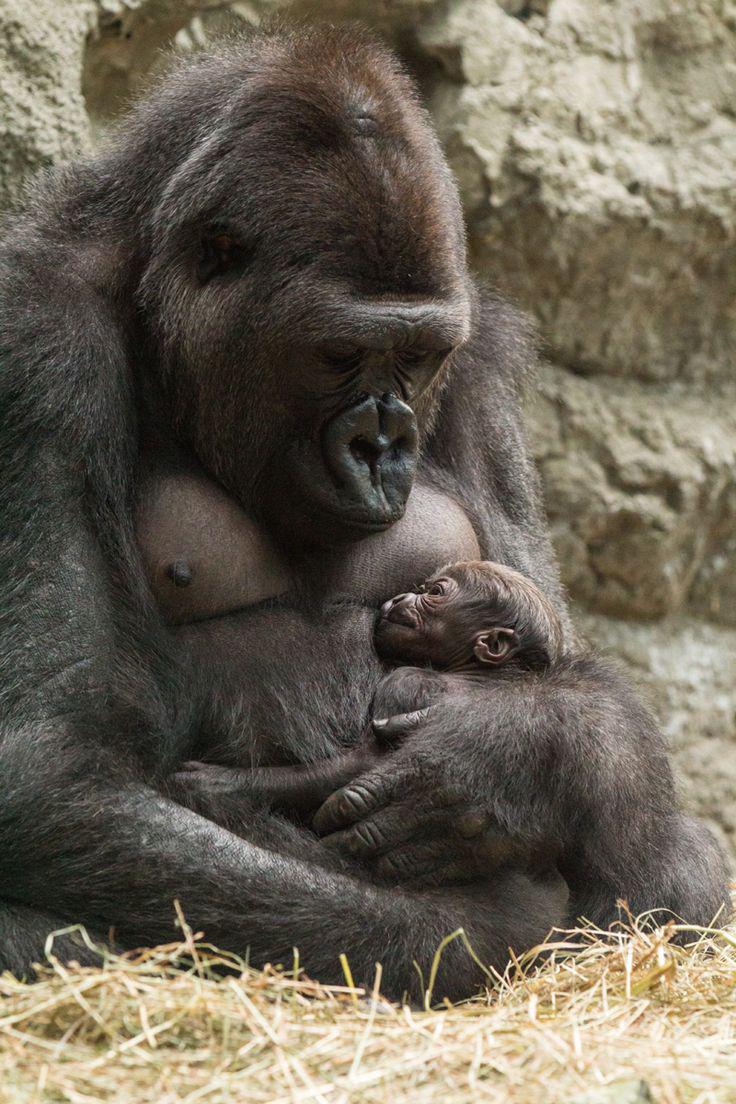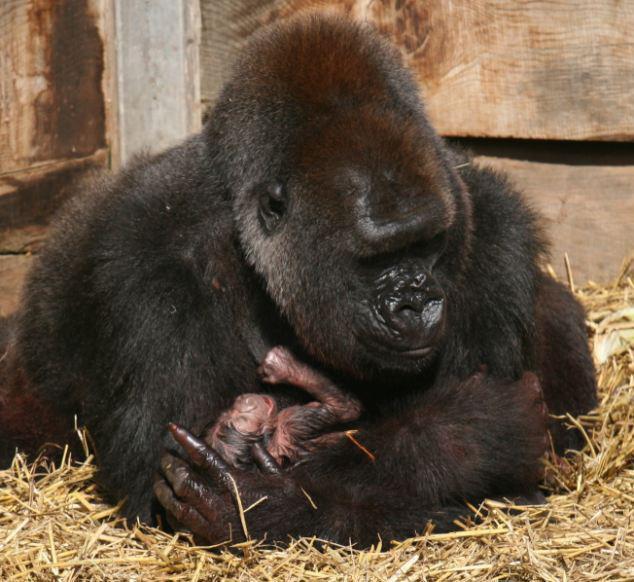The first image is the image on the left, the second image is the image on the right. Examine the images to the left and right. Is the description "The gorilla in the image on the left is lying with the top of its head pointed left." accurate? Answer yes or no. No. The first image is the image on the left, the second image is the image on the right. Given the left and right images, does the statement "The left image shows a mother gorilla nursing her baby, sitting with her back to the left and her head raised and turned to gaze somewhat forward." hold true? Answer yes or no. No. 